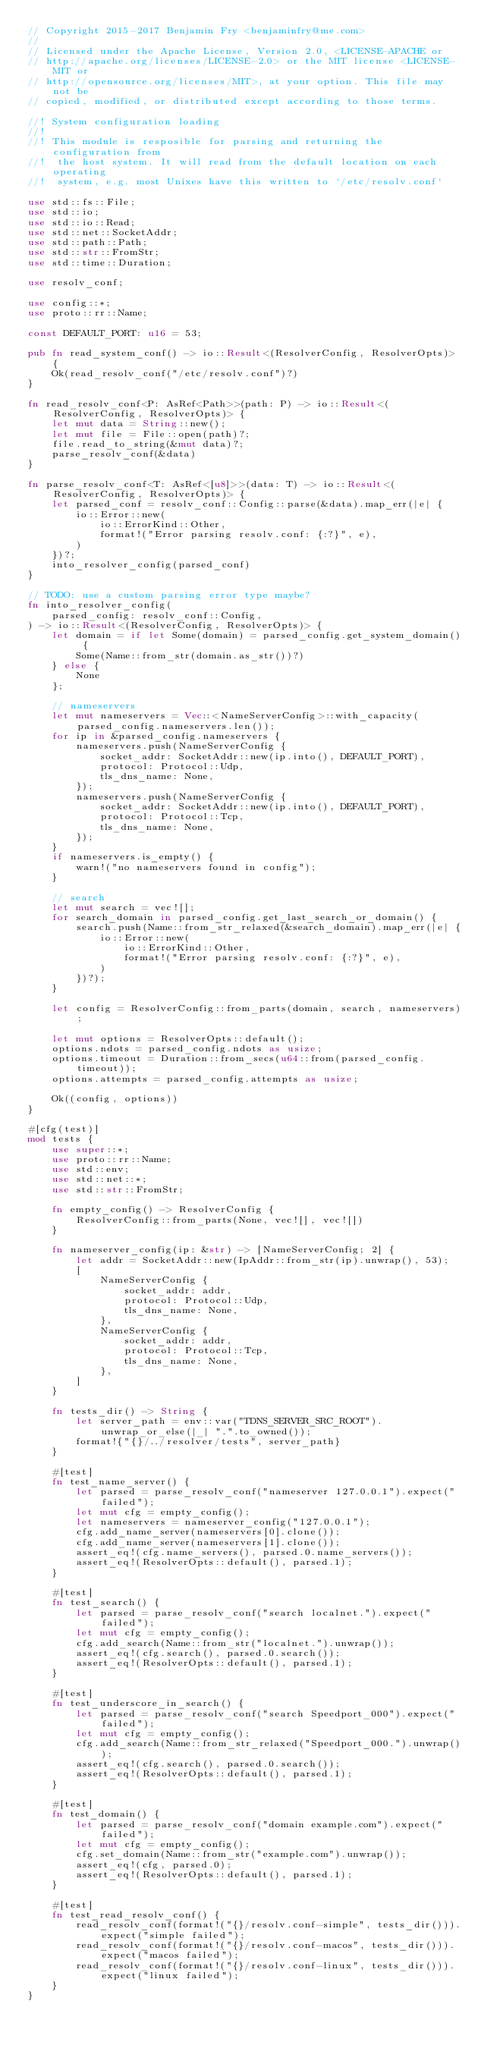Convert code to text. <code><loc_0><loc_0><loc_500><loc_500><_Rust_>// Copyright 2015-2017 Benjamin Fry <benjaminfry@me.com>
//
// Licensed under the Apache License, Version 2.0, <LICENSE-APACHE or
// http://apache.org/licenses/LICENSE-2.0> or the MIT license <LICENSE-MIT or
// http://opensource.org/licenses/MIT>, at your option. This file may not be
// copied, modified, or distributed except according to those terms.

//! System configuration loading
//!
//! This module is resposible for parsing and returning the configuration from
//!  the host system. It will read from the default location on each operating
//!  system, e.g. most Unixes have this written to `/etc/resolv.conf`

use std::fs::File;
use std::io;
use std::io::Read;
use std::net::SocketAddr;
use std::path::Path;
use std::str::FromStr;
use std::time::Duration;

use resolv_conf;

use config::*;
use proto::rr::Name;

const DEFAULT_PORT: u16 = 53;

pub fn read_system_conf() -> io::Result<(ResolverConfig, ResolverOpts)> {
    Ok(read_resolv_conf("/etc/resolv.conf")?)
}

fn read_resolv_conf<P: AsRef<Path>>(path: P) -> io::Result<(ResolverConfig, ResolverOpts)> {
    let mut data = String::new();
    let mut file = File::open(path)?;
    file.read_to_string(&mut data)?;
    parse_resolv_conf(&data)
}

fn parse_resolv_conf<T: AsRef<[u8]>>(data: T) -> io::Result<(ResolverConfig, ResolverOpts)> {
    let parsed_conf = resolv_conf::Config::parse(&data).map_err(|e| {
        io::Error::new(
            io::ErrorKind::Other,
            format!("Error parsing resolv.conf: {:?}", e),
        )
    })?;
    into_resolver_config(parsed_conf)
}

// TODO: use a custom parsing error type maybe?
fn into_resolver_config(
    parsed_config: resolv_conf::Config,
) -> io::Result<(ResolverConfig, ResolverOpts)> {
    let domain = if let Some(domain) = parsed_config.get_system_domain() {
        Some(Name::from_str(domain.as_str())?)
    } else {
        None
    };

    // nameservers
    let mut nameservers = Vec::<NameServerConfig>::with_capacity(parsed_config.nameservers.len());
    for ip in &parsed_config.nameservers {
        nameservers.push(NameServerConfig {
            socket_addr: SocketAddr::new(ip.into(), DEFAULT_PORT),
            protocol: Protocol::Udp,
            tls_dns_name: None,
        });
        nameservers.push(NameServerConfig {
            socket_addr: SocketAddr::new(ip.into(), DEFAULT_PORT),
            protocol: Protocol::Tcp,
            tls_dns_name: None,
        });
    }
    if nameservers.is_empty() {
        warn!("no nameservers found in config");
    }

    // search
    let mut search = vec![];
    for search_domain in parsed_config.get_last_search_or_domain() {
        search.push(Name::from_str_relaxed(&search_domain).map_err(|e| {
            io::Error::new(
                io::ErrorKind::Other,
                format!("Error parsing resolv.conf: {:?}", e),
            )
        })?);
    }

    let config = ResolverConfig::from_parts(domain, search, nameservers);

    let mut options = ResolverOpts::default();
    options.ndots = parsed_config.ndots as usize;
    options.timeout = Duration::from_secs(u64::from(parsed_config.timeout));
    options.attempts = parsed_config.attempts as usize;

    Ok((config, options))
}

#[cfg(test)]
mod tests {
    use super::*;
    use proto::rr::Name;
    use std::env;
    use std::net::*;
    use std::str::FromStr;

    fn empty_config() -> ResolverConfig {
        ResolverConfig::from_parts(None, vec![], vec![])
    }

    fn nameserver_config(ip: &str) -> [NameServerConfig; 2] {
        let addr = SocketAddr::new(IpAddr::from_str(ip).unwrap(), 53);
        [
            NameServerConfig {
                socket_addr: addr,
                protocol: Protocol::Udp,
                tls_dns_name: None,
            },
            NameServerConfig {
                socket_addr: addr,
                protocol: Protocol::Tcp,
                tls_dns_name: None,
            },
        ]
    }

    fn tests_dir() -> String {
        let server_path = env::var("TDNS_SERVER_SRC_ROOT").unwrap_or_else(|_| ".".to_owned());
        format!{"{}/../resolver/tests", server_path}
    }

    #[test]
    fn test_name_server() {
        let parsed = parse_resolv_conf("nameserver 127.0.0.1").expect("failed");
        let mut cfg = empty_config();
        let nameservers = nameserver_config("127.0.0.1");
        cfg.add_name_server(nameservers[0].clone());
        cfg.add_name_server(nameservers[1].clone());
        assert_eq!(cfg.name_servers(), parsed.0.name_servers());
        assert_eq!(ResolverOpts::default(), parsed.1);
    }

    #[test]
    fn test_search() {
        let parsed = parse_resolv_conf("search localnet.").expect("failed");
        let mut cfg = empty_config();
        cfg.add_search(Name::from_str("localnet.").unwrap());
        assert_eq!(cfg.search(), parsed.0.search());
        assert_eq!(ResolverOpts::default(), parsed.1);
    }

    #[test]
    fn test_underscore_in_search() {
        let parsed = parse_resolv_conf("search Speedport_000").expect("failed");
        let mut cfg = empty_config();
        cfg.add_search(Name::from_str_relaxed("Speedport_000.").unwrap());
        assert_eq!(cfg.search(), parsed.0.search());
        assert_eq!(ResolverOpts::default(), parsed.1);
    }

    #[test]
    fn test_domain() {
        let parsed = parse_resolv_conf("domain example.com").expect("failed");
        let mut cfg = empty_config();
        cfg.set_domain(Name::from_str("example.com").unwrap());
        assert_eq!(cfg, parsed.0);
        assert_eq!(ResolverOpts::default(), parsed.1);
    }

    #[test]
    fn test_read_resolv_conf() {
        read_resolv_conf(format!("{}/resolv.conf-simple", tests_dir())).expect("simple failed");
        read_resolv_conf(format!("{}/resolv.conf-macos", tests_dir())).expect("macos failed");
        read_resolv_conf(format!("{}/resolv.conf-linux", tests_dir())).expect("linux failed");
    }
}
</code> 